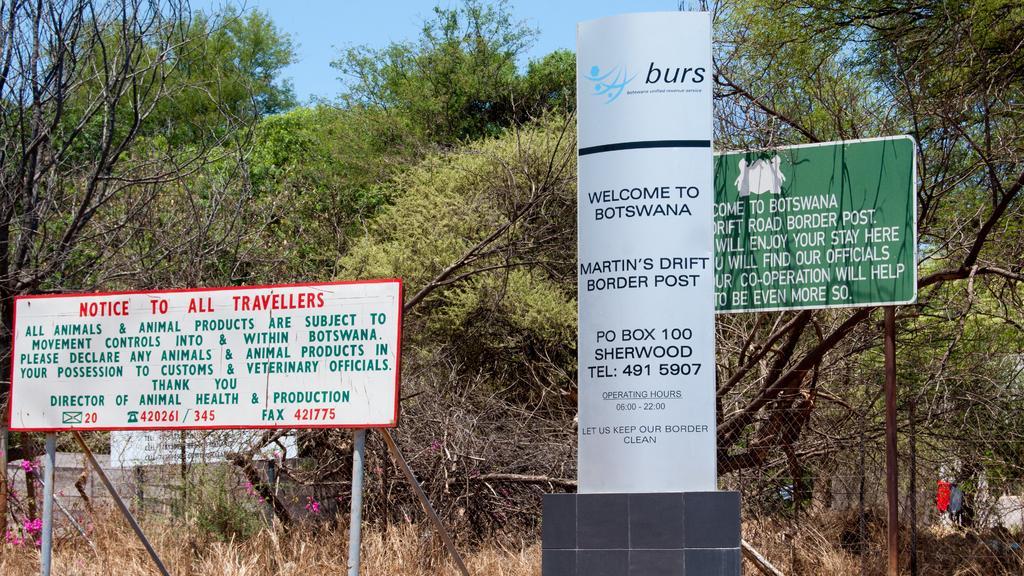In one or two sentences, can you explain what this image depicts? In this image I can see few boards, poles, net fencing, trees, pink color flowers, sky and the dry grass. 